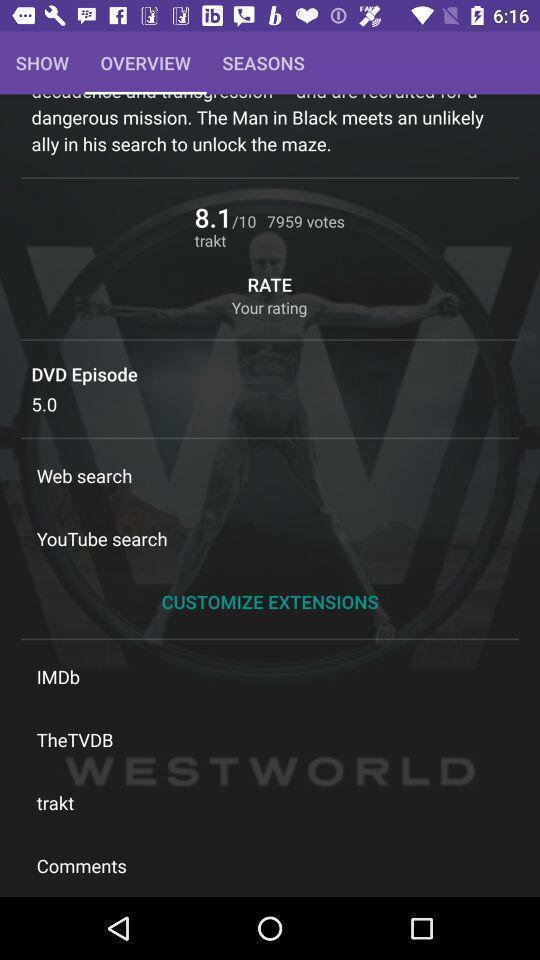What is the overall content of this screenshot? Screen showing overview page. 